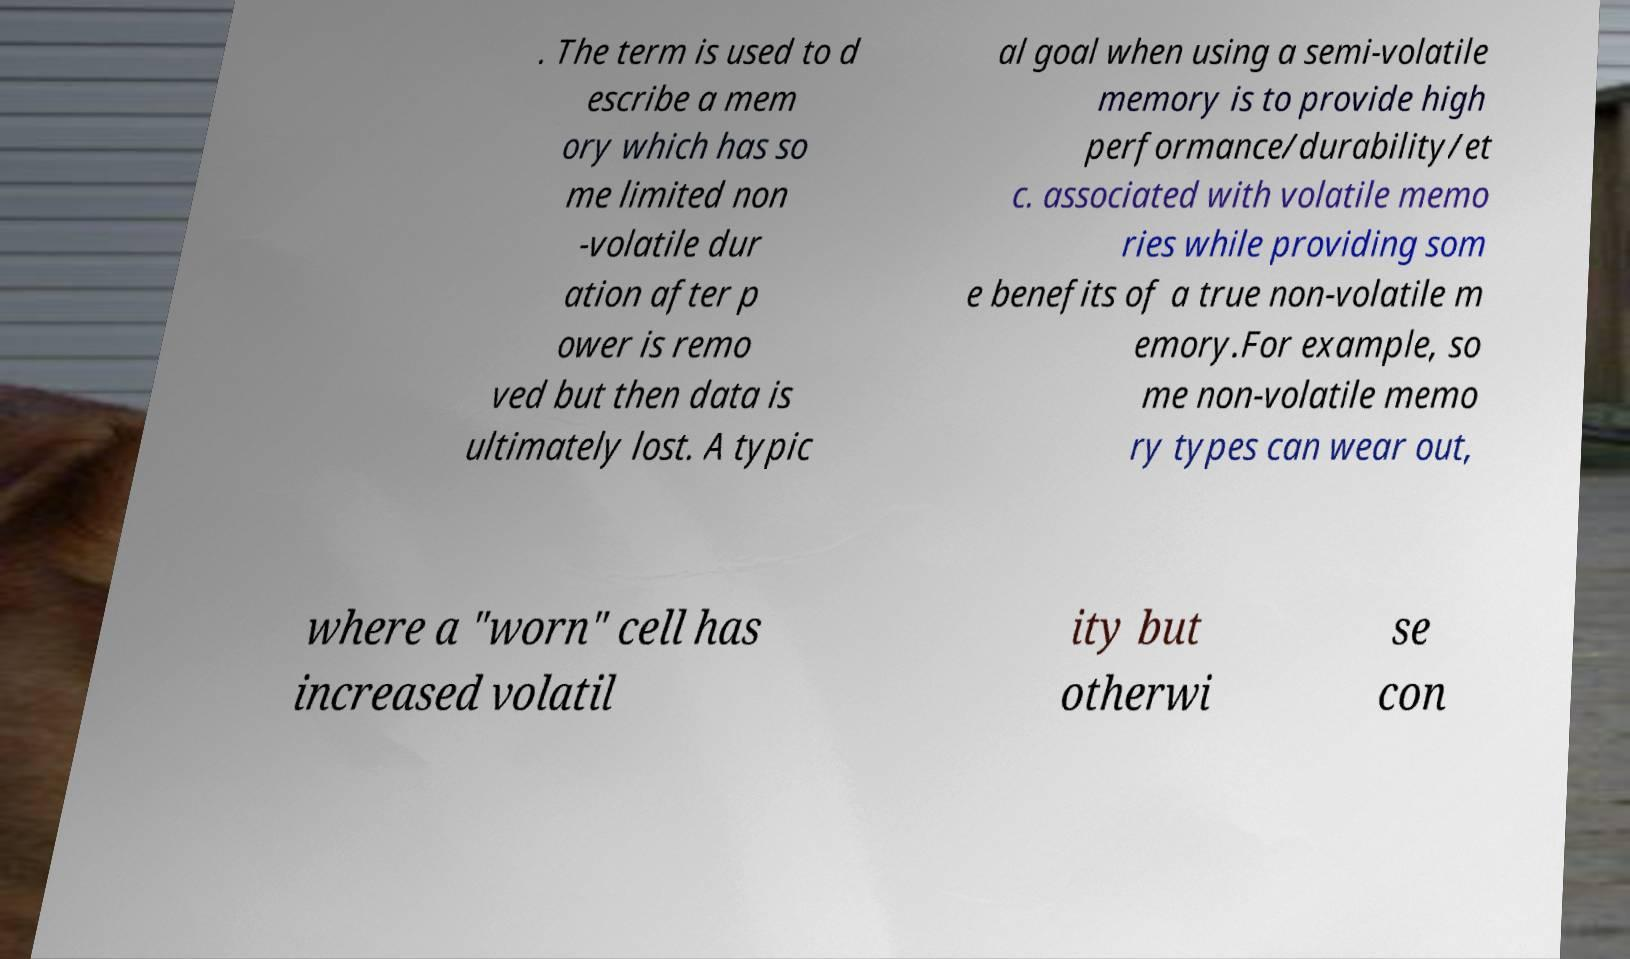Can you accurately transcribe the text from the provided image for me? . The term is used to d escribe a mem ory which has so me limited non -volatile dur ation after p ower is remo ved but then data is ultimately lost. A typic al goal when using a semi-volatile memory is to provide high performance/durability/et c. associated with volatile memo ries while providing som e benefits of a true non-volatile m emory.For example, so me non-volatile memo ry types can wear out, where a "worn" cell has increased volatil ity but otherwi se con 